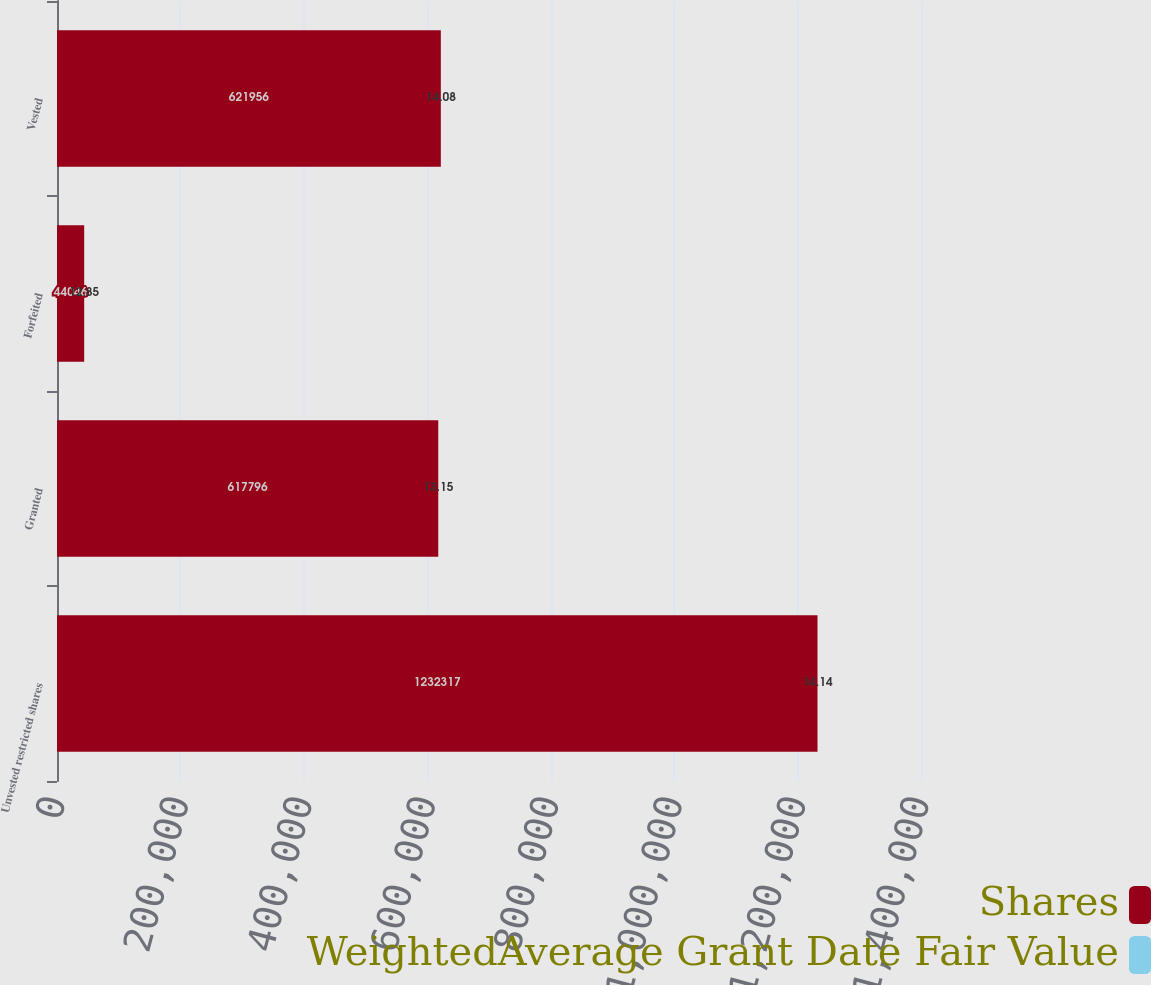<chart> <loc_0><loc_0><loc_500><loc_500><stacked_bar_chart><ecel><fcel>Unvested restricted shares<fcel>Granted<fcel>Forfeited<fcel>Vested<nl><fcel>Shares<fcel>1.23232e+06<fcel>617796<fcel>44046<fcel>621956<nl><fcel>WeightedAverage Grant Date Fair Value<fcel>14.14<fcel>13.15<fcel>12.85<fcel>14.08<nl></chart> 